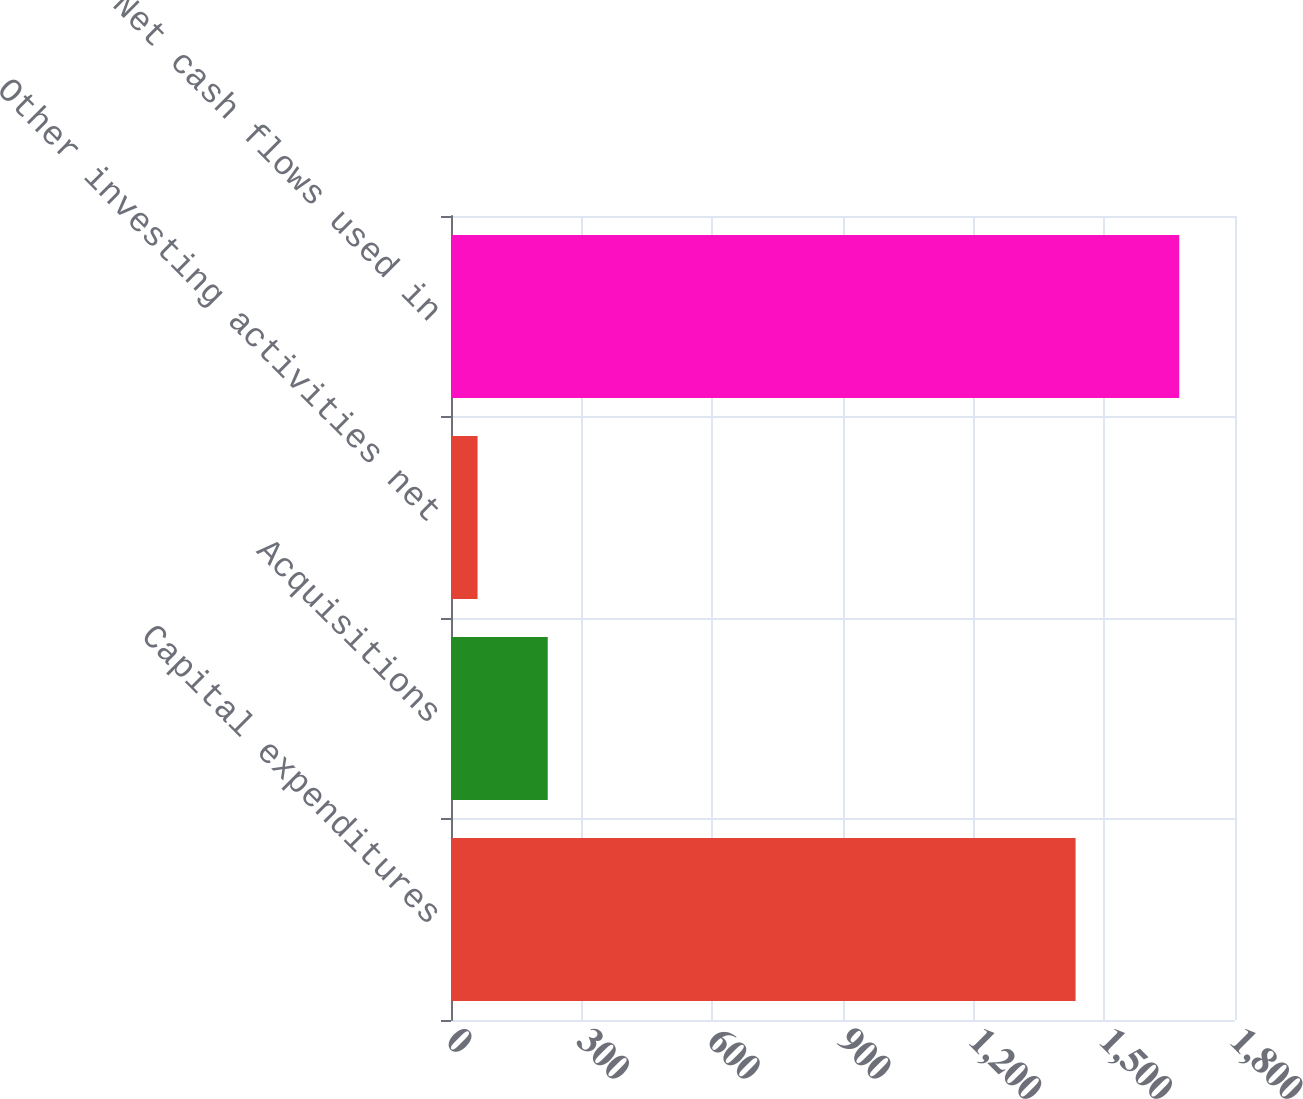<chart> <loc_0><loc_0><loc_500><loc_500><bar_chart><fcel>Capital expenditures<fcel>Acquisitions<fcel>Other investing activities net<fcel>Net cash flows used in<nl><fcel>1434<fcel>222.1<fcel>61<fcel>1672<nl></chart> 